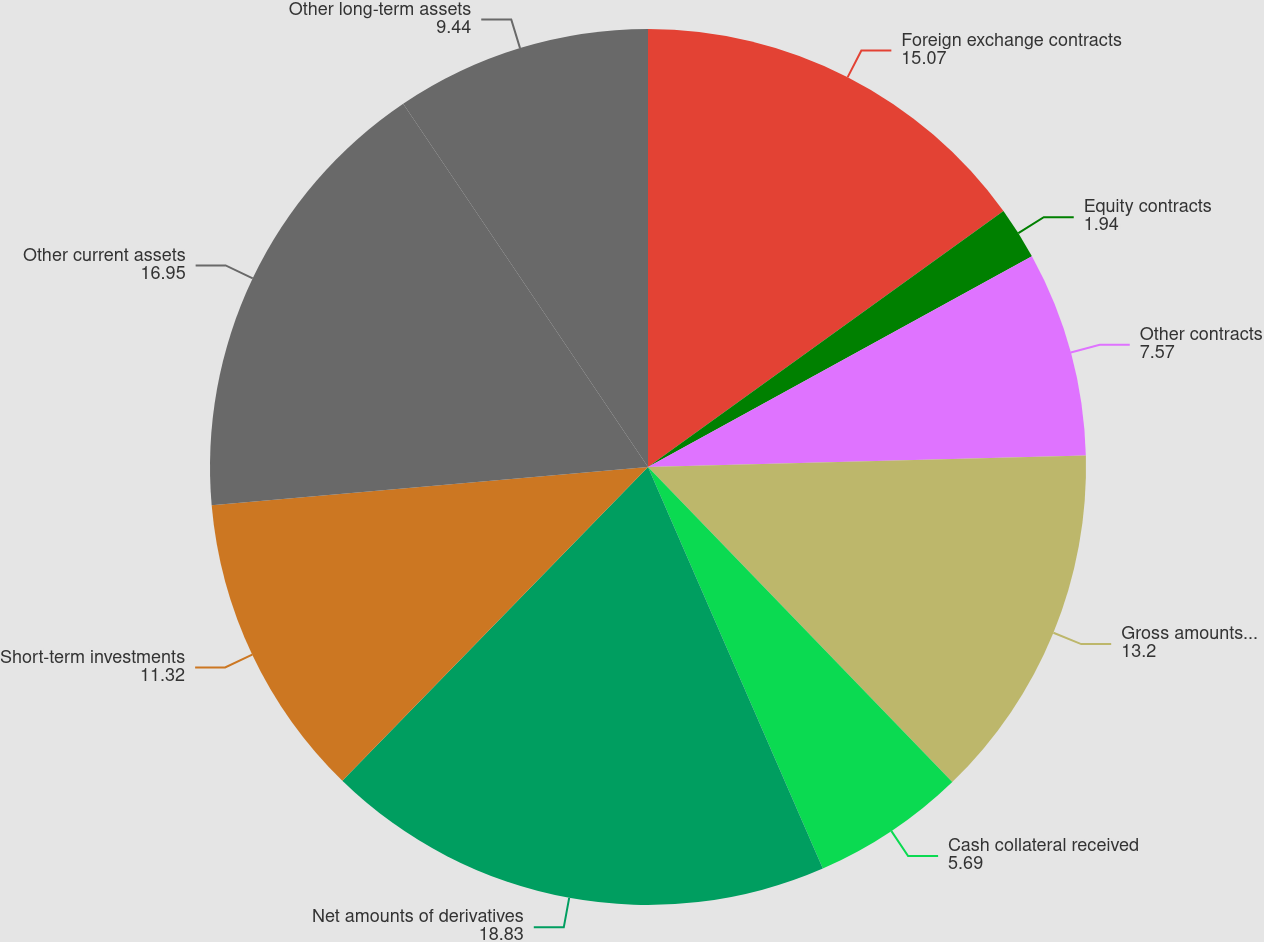Convert chart. <chart><loc_0><loc_0><loc_500><loc_500><pie_chart><fcel>Foreign exchange contracts<fcel>Equity contracts<fcel>Other contracts<fcel>Gross amounts of derivatives<fcel>Cash collateral received<fcel>Net amounts of derivatives<fcel>Short-term investments<fcel>Other current assets<fcel>Other long-term assets<nl><fcel>15.07%<fcel>1.94%<fcel>7.57%<fcel>13.2%<fcel>5.69%<fcel>18.83%<fcel>11.32%<fcel>16.95%<fcel>9.44%<nl></chart> 